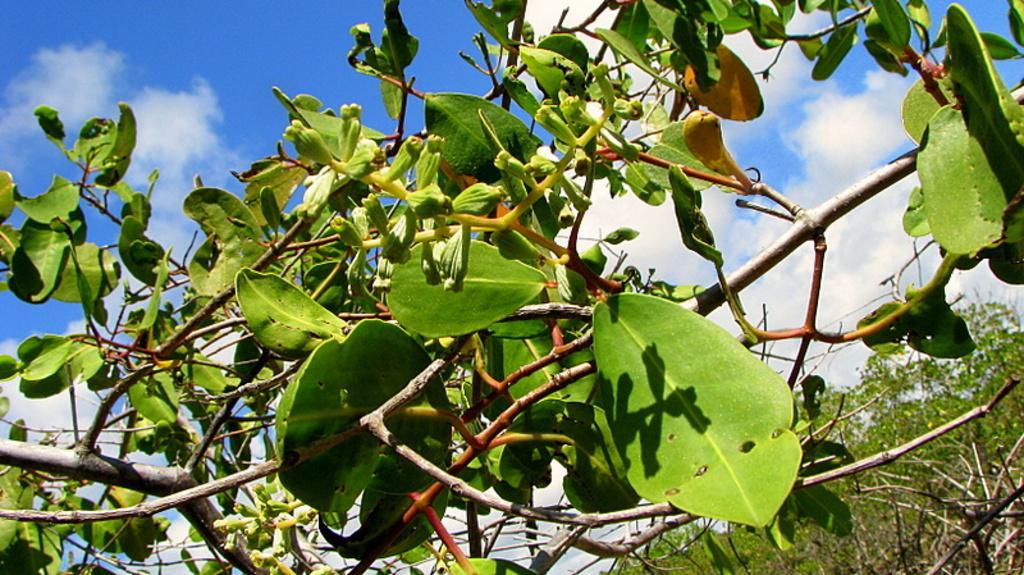How would you summarize this image in a sentence or two? In this image there are few plants having few leaves and flowers. Behind there is tree. Background there is sky with some clouds. 